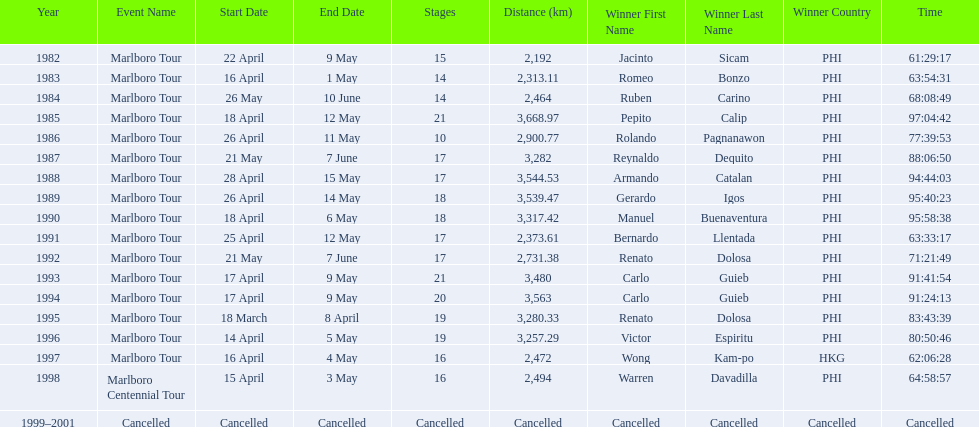What race did warren davadilla compete in in 1998? Marlboro Centennial Tour. How long did it take davadilla to complete the marlboro centennial tour? 64:58:57. 